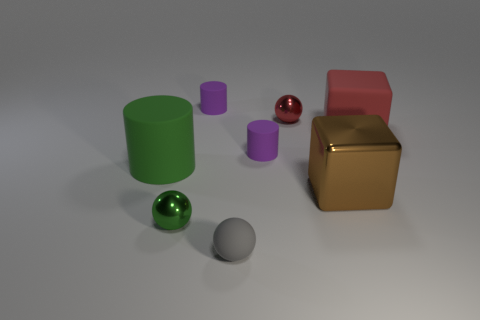How many other things are the same shape as the brown shiny object? There is one object that shares the same cylindrical shape with the brown shiny object, which is the small purple cylinder to the left of the green one. 